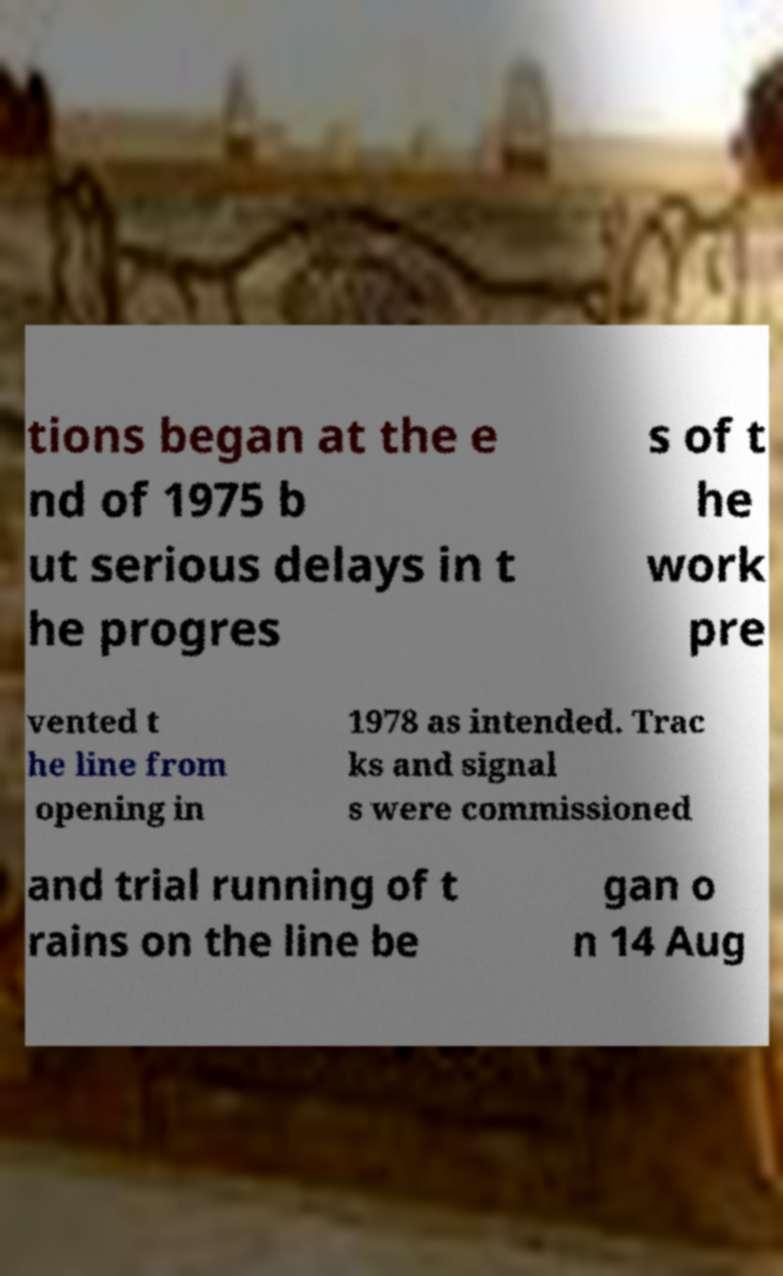Can you accurately transcribe the text from the provided image for me? tions began at the e nd of 1975 b ut serious delays in t he progres s of t he work pre vented t he line from opening in 1978 as intended. Trac ks and signal s were commissioned and trial running of t rains on the line be gan o n 14 Aug 